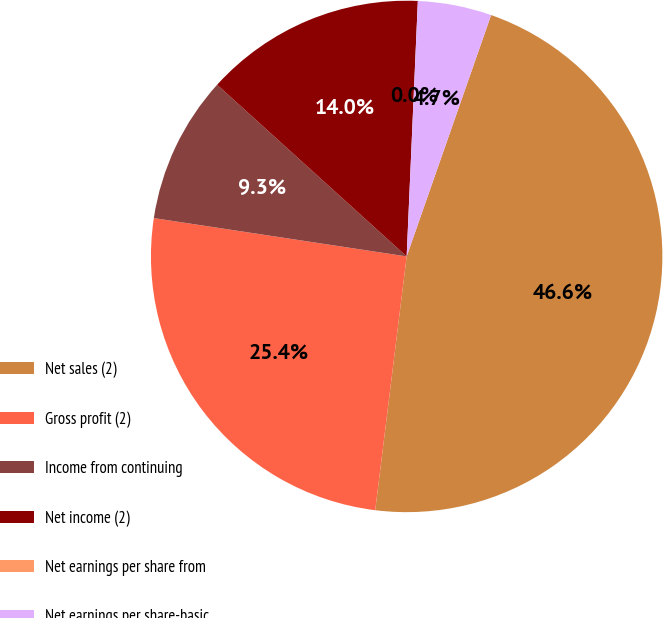Convert chart to OTSL. <chart><loc_0><loc_0><loc_500><loc_500><pie_chart><fcel>Net sales (2)<fcel>Gross profit (2)<fcel>Income from continuing<fcel>Net income (2)<fcel>Net earnings per share from<fcel>Net earnings per share-basic<nl><fcel>46.6%<fcel>25.43%<fcel>9.32%<fcel>13.98%<fcel>0.0%<fcel>4.66%<nl></chart> 